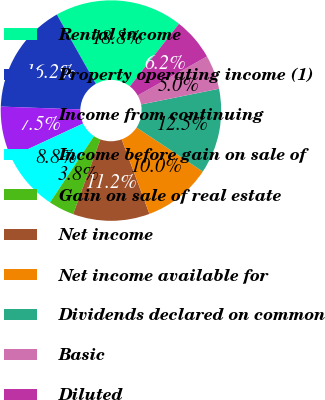<chart> <loc_0><loc_0><loc_500><loc_500><pie_chart><fcel>Rental income<fcel>Property operating income (1)<fcel>Income from continuing<fcel>Income before gain on sale of<fcel>Gain on sale of real estate<fcel>Net income<fcel>Net income available for<fcel>Dividends declared on common<fcel>Basic<fcel>Diluted<nl><fcel>18.75%<fcel>16.25%<fcel>7.5%<fcel>8.75%<fcel>3.75%<fcel>11.25%<fcel>10.0%<fcel>12.5%<fcel>5.0%<fcel>6.25%<nl></chart> 